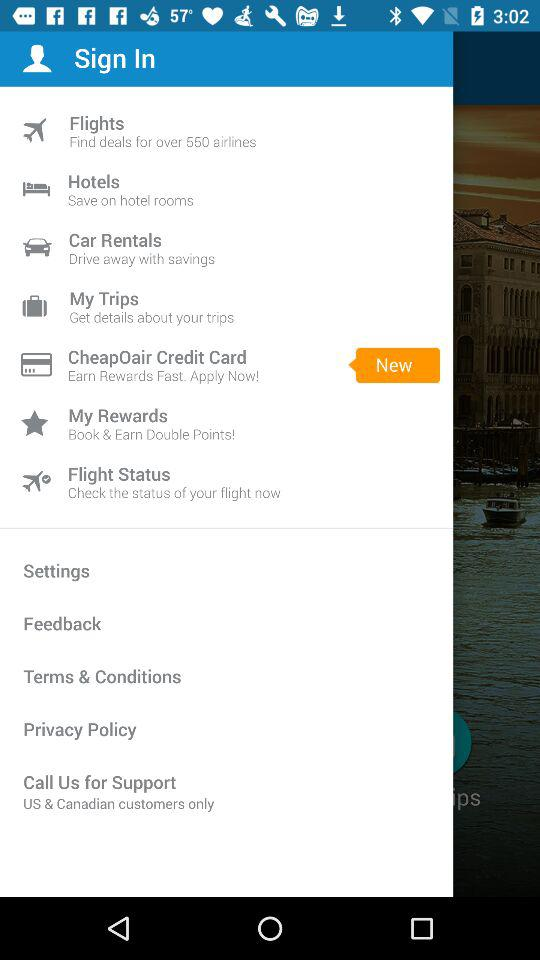What is the newest option? The newest option is the CheapOair Credit Card. 